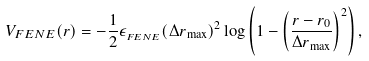Convert formula to latex. <formula><loc_0><loc_0><loc_500><loc_500>V _ { F E N E } ( r ) = - \frac { 1 } { 2 } \epsilon _ { _ { F E N E } } ( \Delta r _ { \max } ) ^ { 2 } \log \left ( 1 - \left ( \frac { r - r _ { 0 } } { \Delta r _ { \max } } \right ) ^ { 2 } \right ) ,</formula> 